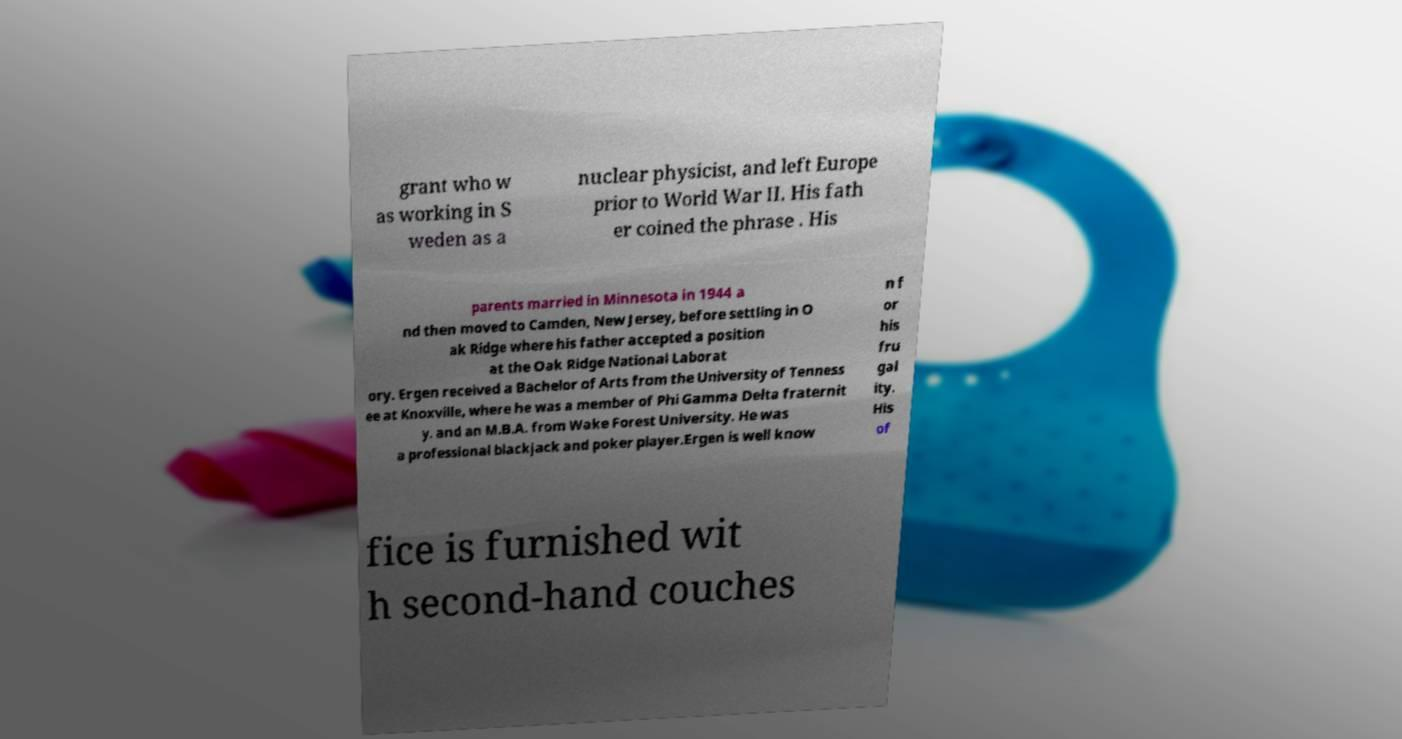Could you extract and type out the text from this image? grant who w as working in S weden as a nuclear physicist, and left Europe prior to World War II. His fath er coined the phrase . His parents married in Minnesota in 1944 a nd then moved to Camden, New Jersey, before settling in O ak Ridge where his father accepted a position at the Oak Ridge National Laborat ory. Ergen received a Bachelor of Arts from the University of Tenness ee at Knoxville, where he was a member of Phi Gamma Delta fraternit y. and an M.B.A. from Wake Forest University. He was a professional blackjack and poker player.Ergen is well know n f or his fru gal ity. His of fice is furnished wit h second-hand couches 